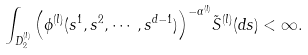Convert formula to latex. <formula><loc_0><loc_0><loc_500><loc_500>\int _ { D _ { 2 } ^ { ( l ) } } { \left ( \phi ^ { ( l ) } ( s ^ { 1 } , s ^ { 2 } , \cdots , s ^ { d - 1 } ) \right ) } ^ { - \alpha ^ { ( l ) } } \tilde { S } ^ { ( l ) } ( d { s } ) < \infty .</formula> 